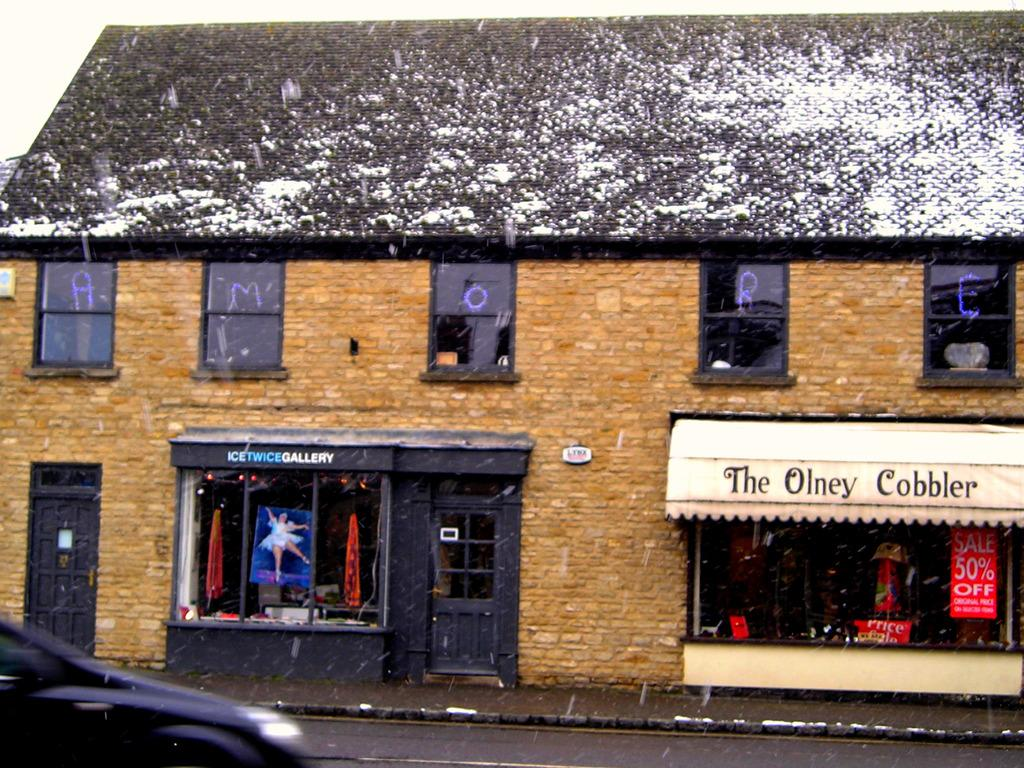What type of establishment is shown in the image? There is a restaurant in the image. Can you describe any other objects or vehicles in the image? Yes, there is a vehicle in the bottom left of the image. How many tomatoes are hanging on the wall inside the restaurant? There is no information about tomatoes or any wall decorations inside the restaurant in the image. 